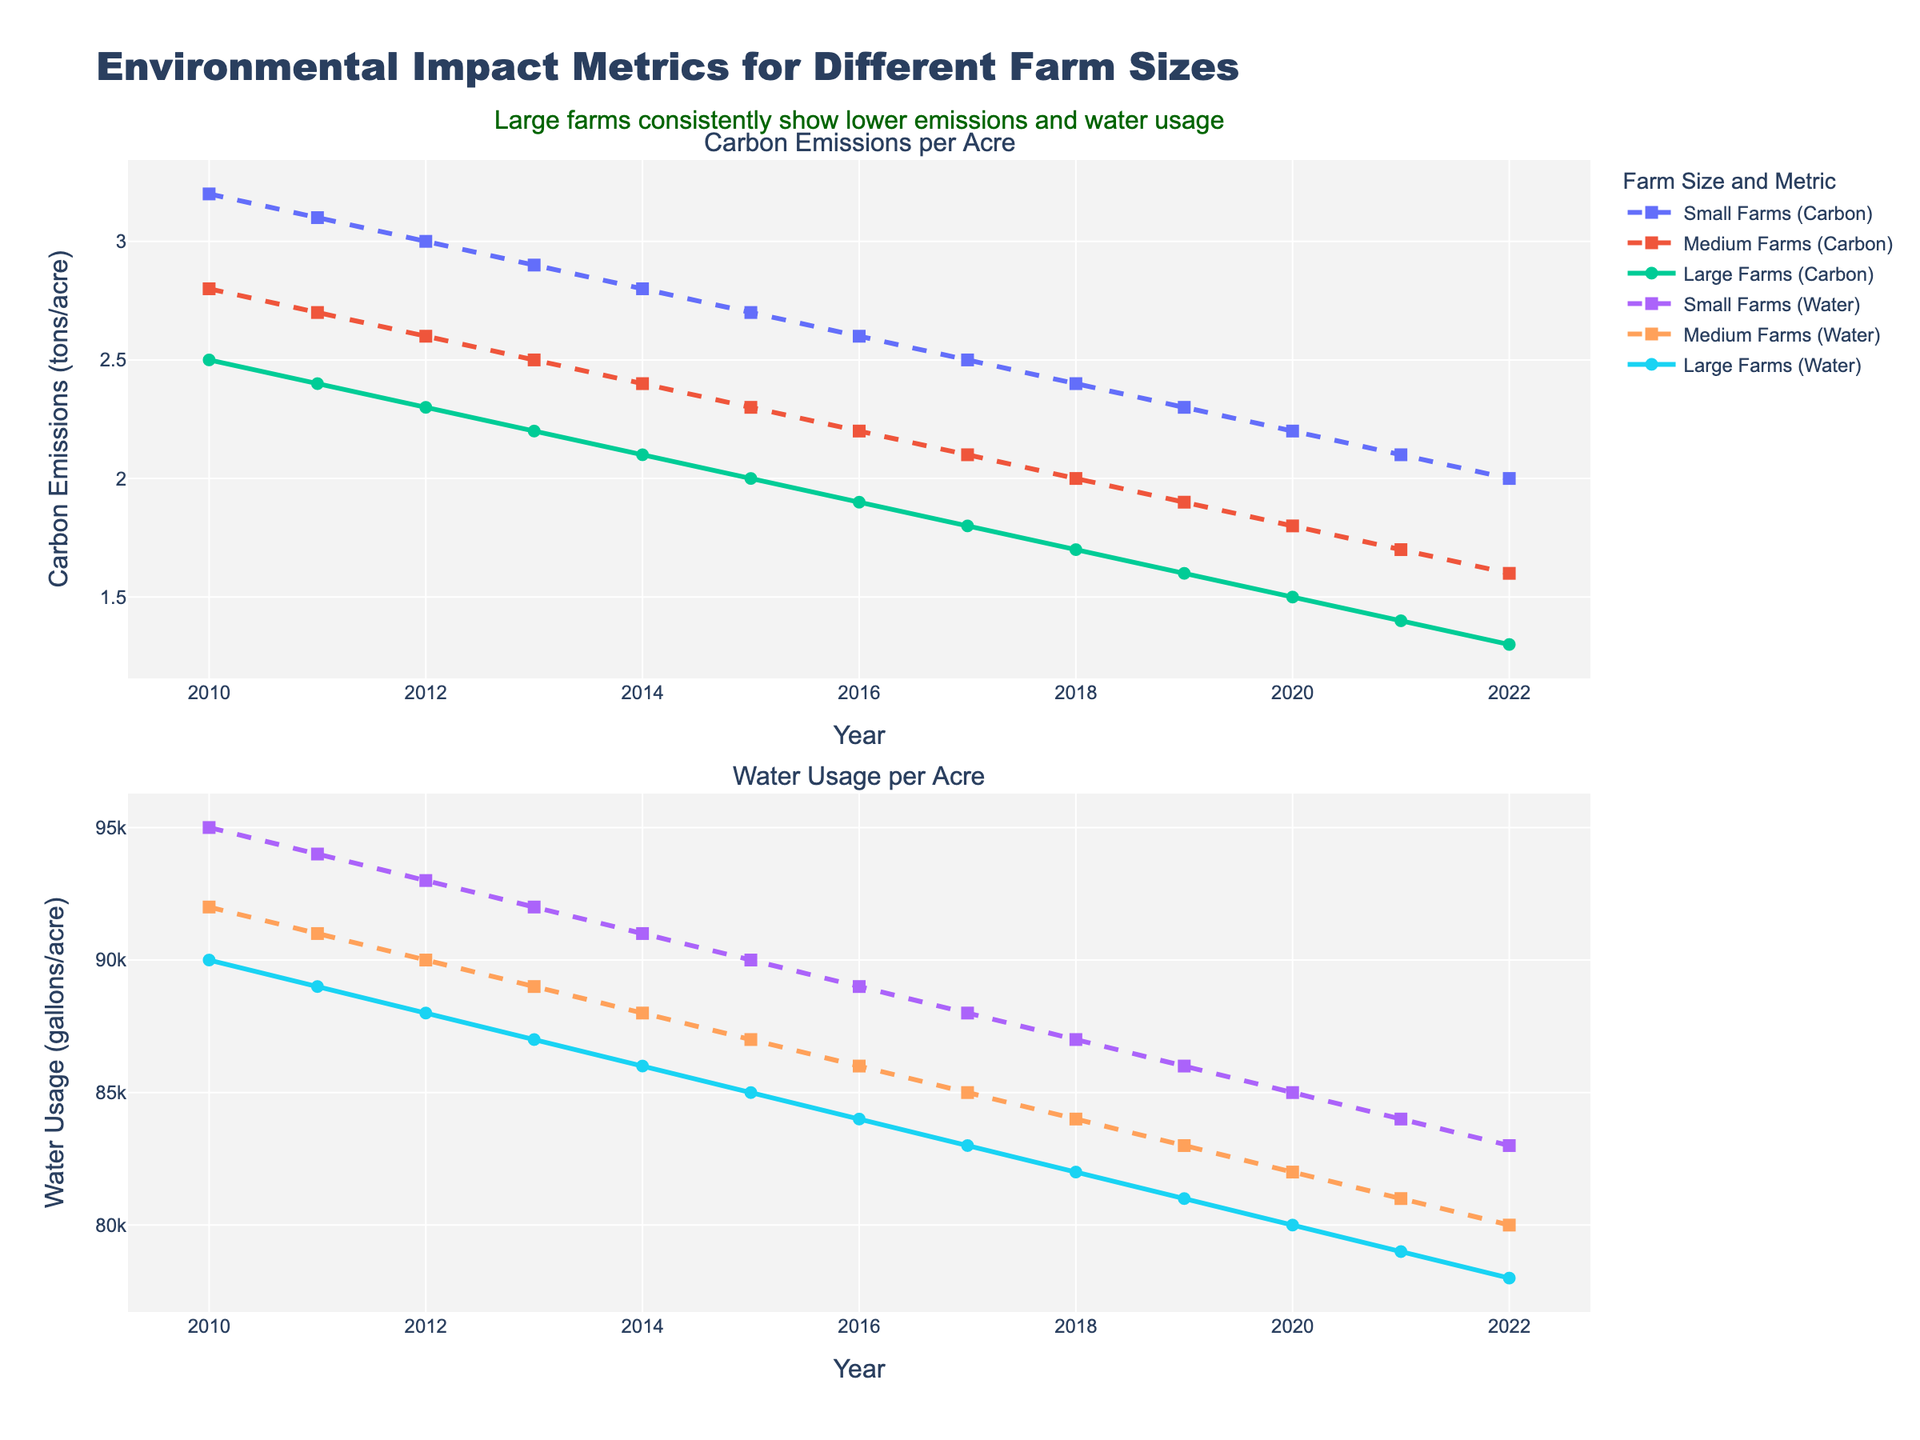What is the difference in carbon emissions per acre between small farms and large farms in 2010? In 2010, small farms have carbon emissions of 3.2 tons/acre and large farms have 2.5 tons/acre. The difference is 3.2 - 2.5.
Answer: 0.7 tons/acre How have carbon emissions per acre for small farms changed from 2010 to 2022? In 2010, small farms had carbon emissions of 3.2 tons/acre, and by 2022, this number had decreased to 2.0 tons/acre. The change is 3.2 - 2.0.
Answer: Decreased by 1.2 tons/acre Which year shows the lowest water usage per acre for medium farms? The lowest water usage per acre for medium farms can be seen from the second plot where the water usage line for medium farms (dashed) is at its lowest point. The lowest point is in 2022 with 80,000 gallons/acre.
Answer: 2022 What is the average carbon emissions per acre for large farms from 2010 to 2022? To find the average, add up the carbon emissions for large farms from 2010 to 2022, then divide by the number of years. The total is (2.5 + 2.4 + 2.3 + 2.2 + 2.1 + 2.0 + 1.9 + 1.8 + 1.7 + 1.6 + 1.5 + 1.4 + 1.3) = 25.7. Divide this by 13.
Answer: 1.98 tons/acre By how much did the water usage per acre for small farms decrease between 2010 and 2022? In 2010, small farms used 95,000 gallons/acre of water. By 2022, this decreased to 83,000 gallons/acre. The decrease is 95,000 - 83,000.
Answer: 12,000 gallons/acre Which farm size showed the most consistent decrease in carbon emissions per acre over the years? By looking at the first plot, observe the carbon emissions lines for small, medium, and large farms. The line that shows a steady, consistent decline is for large farms, indicated by the solid line.
Answer: Large farms Compare the water usage per acre of small farms and large farms in 2015. In 2015, small farms used 90,000 gallons/acre, and large farms used 85,000 gallons/acre. The difference is 90,000 - 85,000.
Answer: 5,000 gallons/acre What can be inferred about the trend in carbon emissions for all farm sizes from 2010-2022? All three lines representing small, medium, and large farms in the first plot show a downward trend in carbon emissions from 2010 to 2022, indicating a consistent decrease over time.
Answer: Decreasing trend What is the combined water usage per acre for medium and large farms in 2018? In 2018, medium farms used 84,000 gallons/acre and large farms used 82,000 gallons/acre. Sum these values to get the combined usage: 84,000 + 82,000.
Answer: 166,000 gallons/acre Which farm size achieved the lowest carbon emissions per acre in 2022? The first plot shows that in 2022, the line for large farms ends at the lowest point, which is 1.3 tons/acre.
Answer: Large farms 